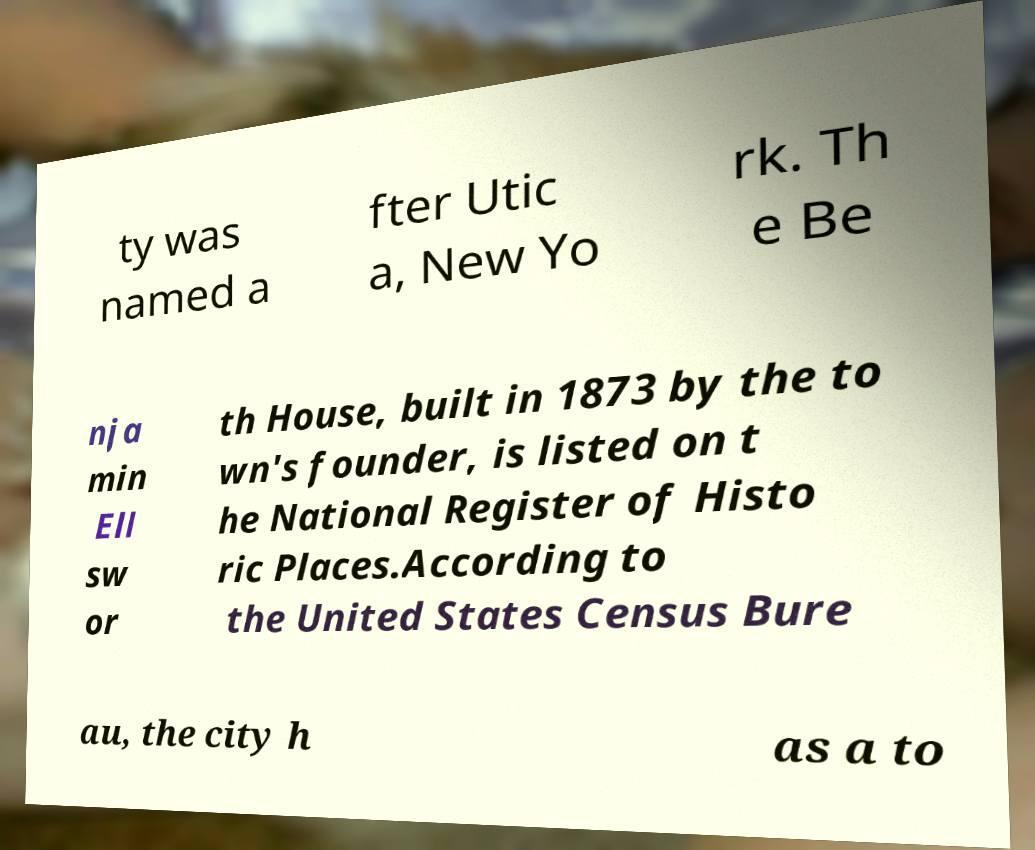I need the written content from this picture converted into text. Can you do that? ty was named a fter Utic a, New Yo rk. Th e Be nja min Ell sw or th House, built in 1873 by the to wn's founder, is listed on t he National Register of Histo ric Places.According to the United States Census Bure au, the city h as a to 